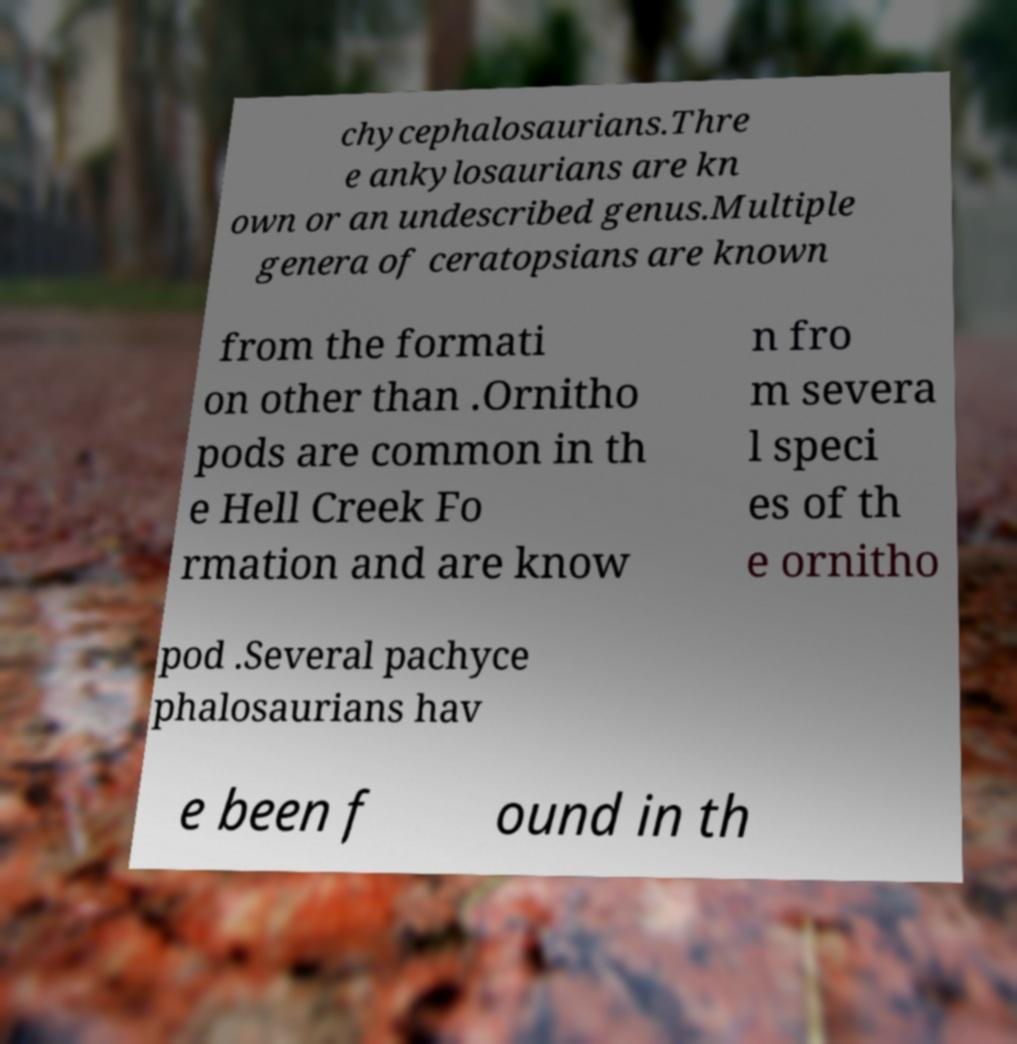Can you accurately transcribe the text from the provided image for me? chycephalosaurians.Thre e ankylosaurians are kn own or an undescribed genus.Multiple genera of ceratopsians are known from the formati on other than .Ornitho pods are common in th e Hell Creek Fo rmation and are know n fro m severa l speci es of th e ornitho pod .Several pachyce phalosaurians hav e been f ound in th 